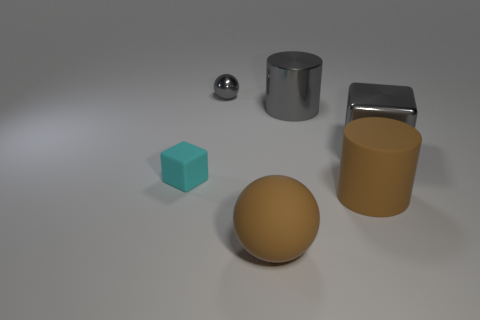What number of things are tiny cyan matte objects or big gray metal cylinders?
Your response must be concise. 2. What is the size of the gray thing in front of the big thing behind the big metal cube?
Provide a short and direct response. Large. The brown rubber sphere has what size?
Offer a very short reply. Large. What shape is the matte thing that is behind the brown rubber ball and on the right side of the cyan matte thing?
Your response must be concise. Cylinder. What is the color of the metal object that is the same shape as the tiny rubber thing?
Provide a succinct answer. Gray. How many things are tiny objects that are in front of the metal block or rubber things on the right side of the gray shiny ball?
Provide a short and direct response. 3. What is the shape of the tiny matte object?
Provide a succinct answer. Cube. What is the shape of the large rubber thing that is the same color as the large matte ball?
Keep it short and to the point. Cylinder. What number of things have the same material as the tiny cyan cube?
Provide a short and direct response. 2. The large shiny cube has what color?
Your answer should be compact. Gray. 